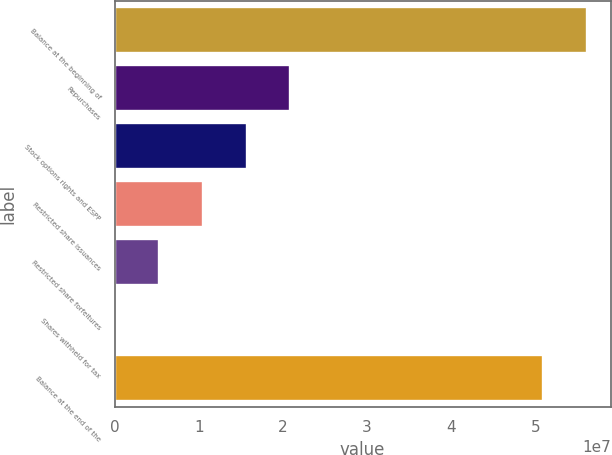Convert chart. <chart><loc_0><loc_0><loc_500><loc_500><bar_chart><fcel>Balance at the beginning of<fcel>Repurchases<fcel>Stock options rights and ESPP<fcel>Restricted share issuances<fcel>Restricted share forfeitures<fcel>Shares withheld for tax<fcel>Balance at the end of the<nl><fcel>5.61106e+07<fcel>2.08811e+07<fcel>1.56788e+07<fcel>1.04765e+07<fcel>5.27412e+06<fcel>71780<fcel>5.09083e+07<nl></chart> 